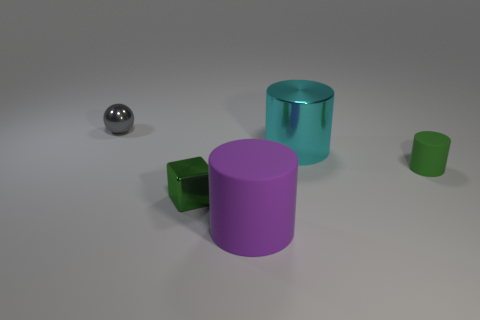There is a object that is made of the same material as the large purple cylinder; what size is it?
Offer a terse response. Small. What number of things are small green rubber things or cyan cylinders?
Offer a terse response. 2. What color is the rubber cylinder on the right side of the metal cylinder?
Ensure brevity in your answer.  Green. The purple matte thing that is the same shape as the cyan shiny thing is what size?
Provide a succinct answer. Large. How many objects are either large things that are in front of the cube or small objects behind the tiny green cube?
Provide a short and direct response. 3. How big is the object that is left of the green rubber cylinder and to the right of the big purple matte object?
Provide a short and direct response. Large. Do the purple rubber thing and the big object that is behind the purple cylinder have the same shape?
Your answer should be compact. Yes. How many things are tiny green cylinders in front of the cyan thing or purple objects?
Make the answer very short. 2. Do the small green cylinder and the purple cylinder in front of the green shiny object have the same material?
Ensure brevity in your answer.  Yes. What is the shape of the small metallic object behind the small shiny object in front of the small gray metallic object?
Provide a succinct answer. Sphere. 